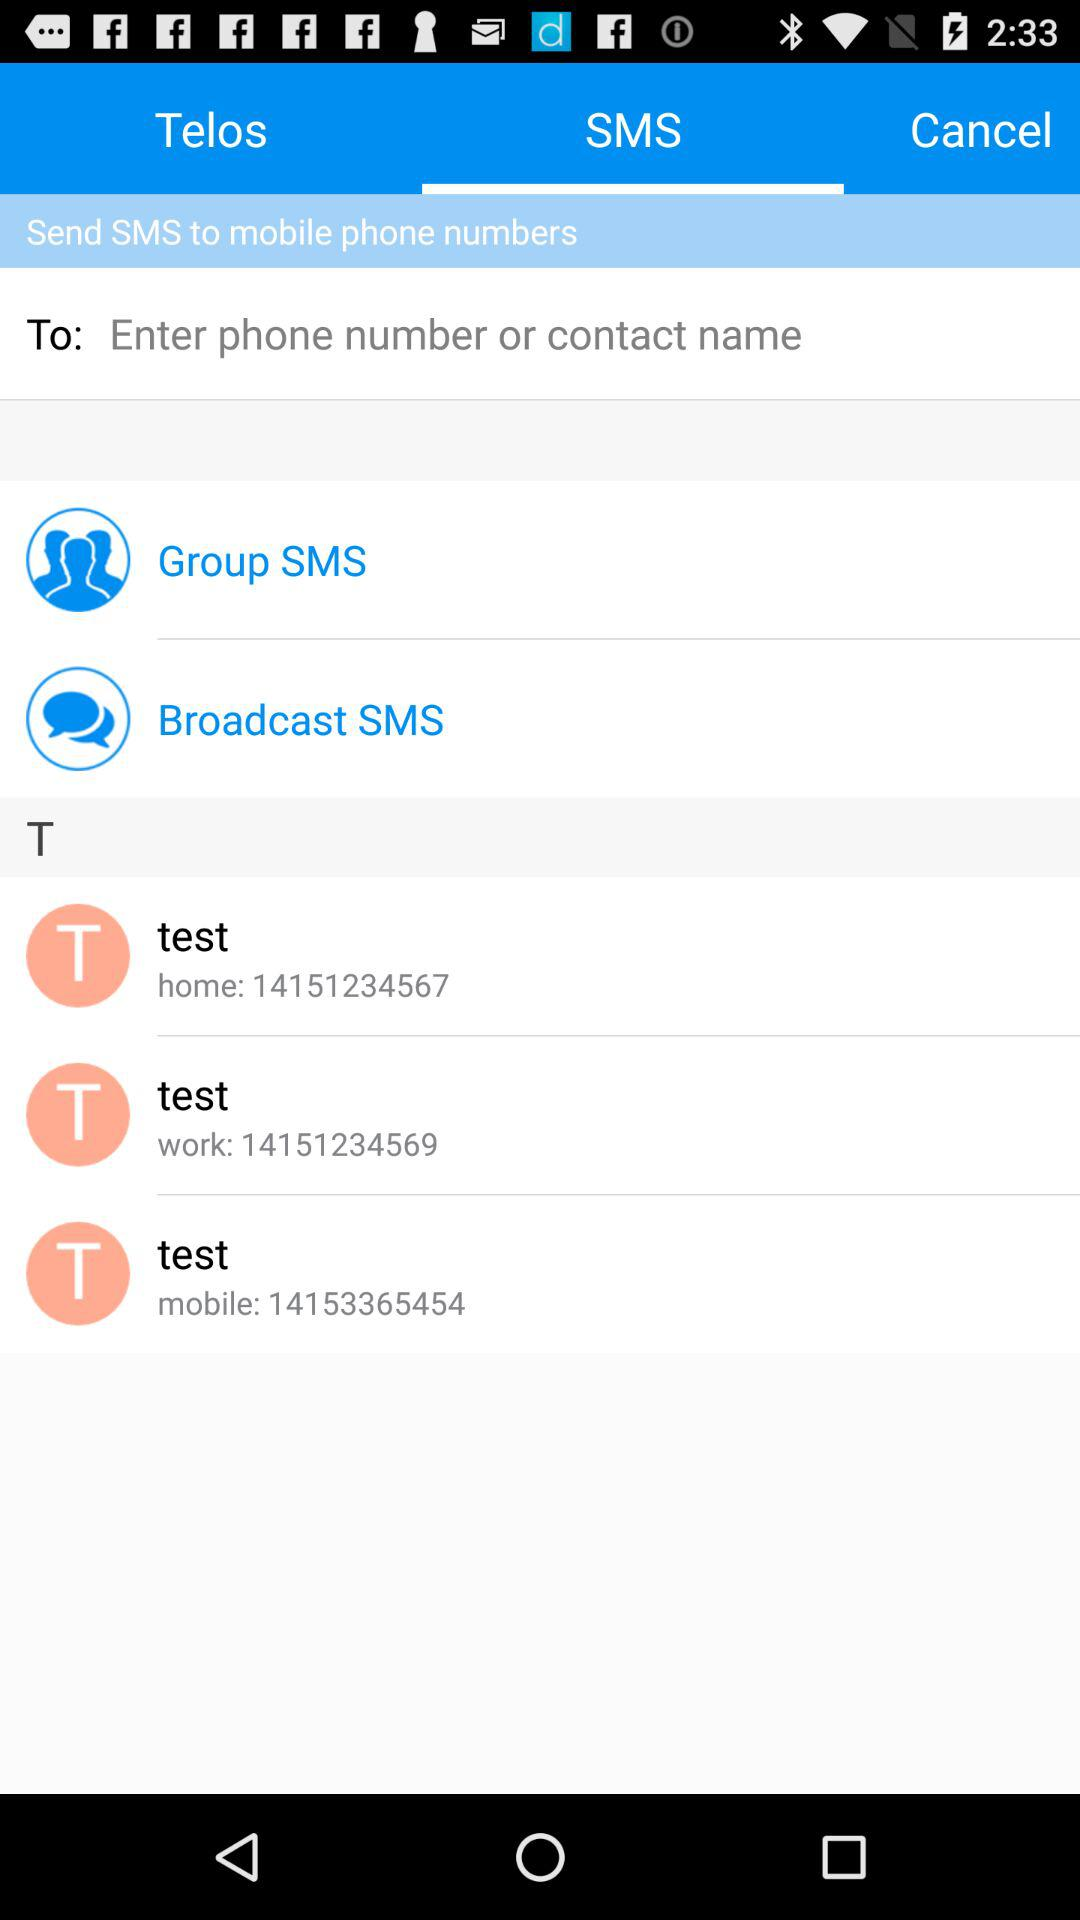What is the home contact number of test? The home contact number is 14151234567. 